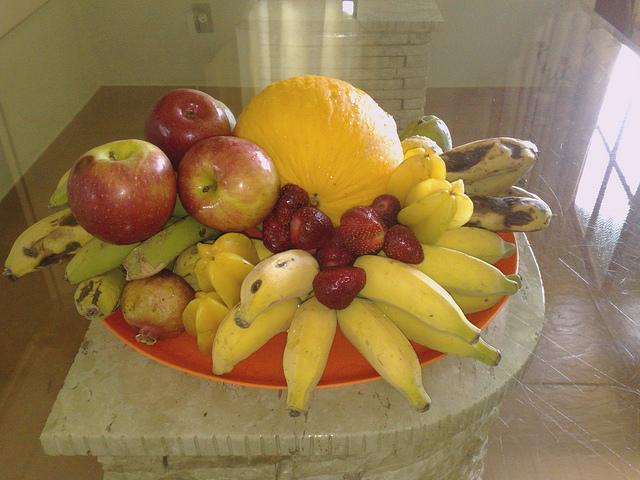How many apples are there?
Give a very brief answer. 3. How many bananas are in the picture?
Give a very brief answer. 7. How many people are there?
Give a very brief answer. 0. 